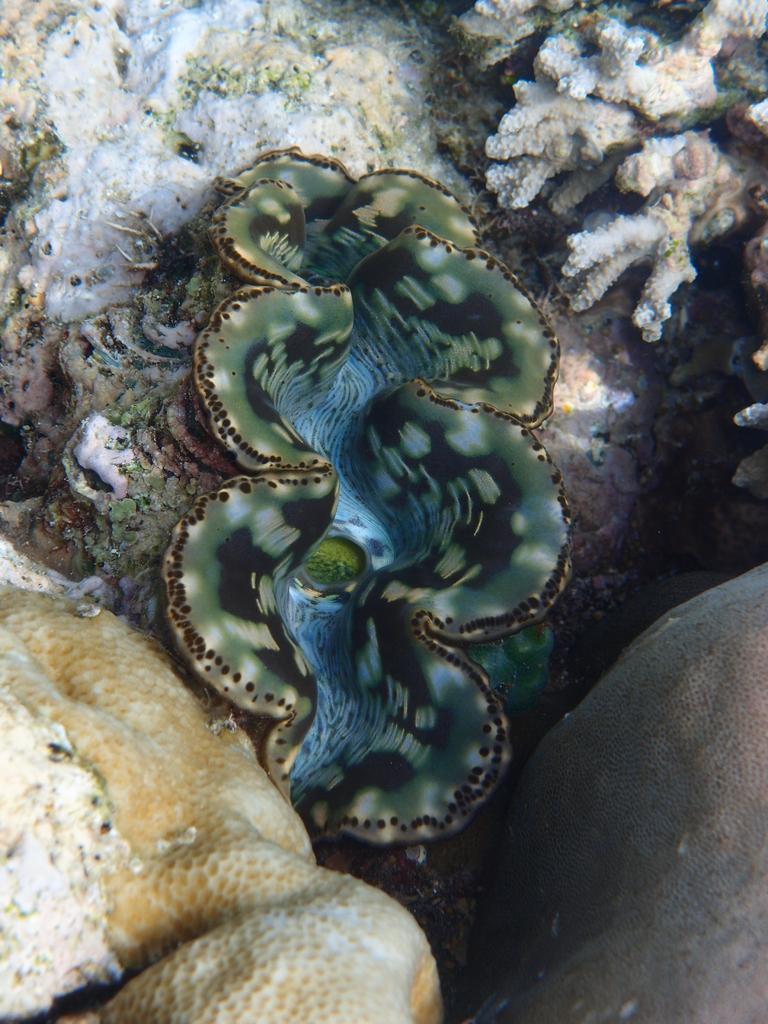Could you give a brief overview of what you see in this image? In this image it looks like a jellyfish and some sea plants in water. 